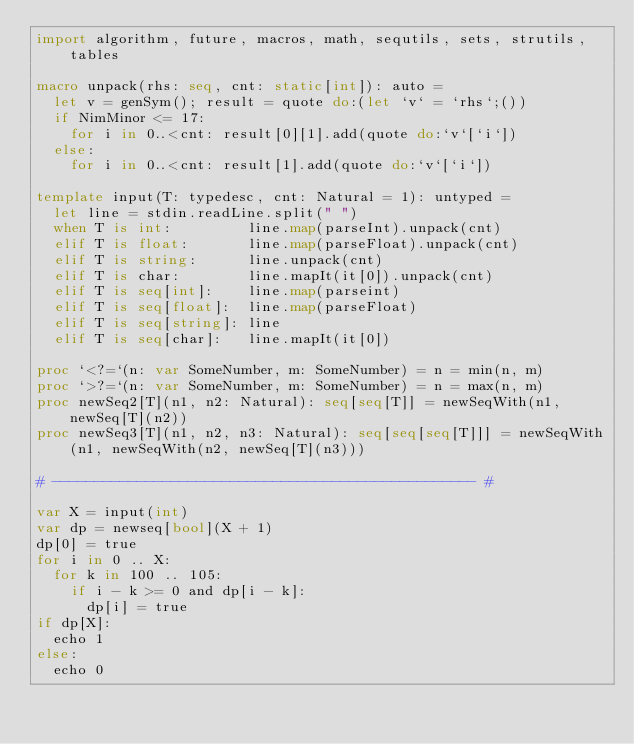Convert code to text. <code><loc_0><loc_0><loc_500><loc_500><_Nim_>import algorithm, future, macros, math, sequtils, sets, strutils, tables

macro unpack(rhs: seq, cnt: static[int]): auto =
  let v = genSym(); result = quote do:(let `v` = `rhs`;())
  if NimMinor <= 17:
    for i in 0..<cnt: result[0][1].add(quote do:`v`[`i`])
  else:
    for i in 0..<cnt: result[1].add(quote do:`v`[`i`])

template input(T: typedesc, cnt: Natural = 1): untyped =
  let line = stdin.readLine.split(" ")
  when T is int:         line.map(parseInt).unpack(cnt)
  elif T is float:       line.map(parseFloat).unpack(cnt)
  elif T is string:      line.unpack(cnt)
  elif T is char:        line.mapIt(it[0]).unpack(cnt)
  elif T is seq[int]:    line.map(parseint)
  elif T is seq[float]:  line.map(parseFloat)
  elif T is seq[string]: line
  elif T is seq[char]:   line.mapIt(it[0])

proc `<?=`(n: var SomeNumber, m: SomeNumber) = n = min(n, m)
proc `>?=`(n: var SomeNumber, m: SomeNumber) = n = max(n, m)
proc newSeq2[T](n1, n2: Natural): seq[seq[T]] = newSeqWith(n1, newSeq[T](n2))
proc newSeq3[T](n1, n2, n3: Natural): seq[seq[seq[T]]] = newSeqWith(n1, newSeqWith(n2, newSeq[T](n3)))

# -------------------------------------------------- #

var X = input(int)
var dp = newseq[bool](X + 1)
dp[0] = true
for i in 0 .. X:
  for k in 100 .. 105:
    if i - k >= 0 and dp[i - k]:
      dp[i] = true
if dp[X]:
  echo 1
else:
  echo 0</code> 